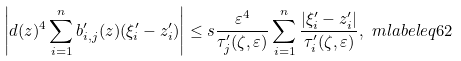Convert formula to latex. <formula><loc_0><loc_0><loc_500><loc_500>\left | d ( z ) ^ { 4 } \sum _ { i = 1 } ^ { n } b ^ { \prime } _ { i , j } ( z ) ( \xi ^ { \prime } _ { i } - z ^ { \prime } _ { i } ) \right | & \leq s \frac { \varepsilon ^ { 4 } } { \tau ^ { \prime } _ { j } ( \zeta , \varepsilon ) } \sum _ { i = 1 } ^ { n } \frac { \left | \xi ^ { \prime } _ { i } - z ^ { \prime } _ { i } \right | } { \tau ^ { \prime } _ { i } ( \zeta , \varepsilon ) } , \ m l a b e l { e q 6 2 }</formula> 